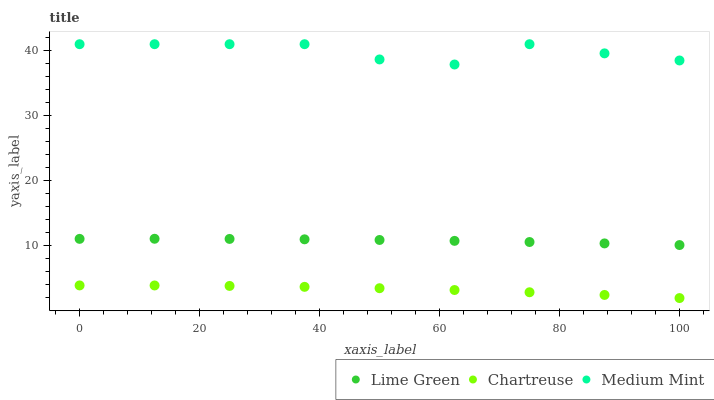Does Chartreuse have the minimum area under the curve?
Answer yes or no. Yes. Does Medium Mint have the maximum area under the curve?
Answer yes or no. Yes. Does Lime Green have the minimum area under the curve?
Answer yes or no. No. Does Lime Green have the maximum area under the curve?
Answer yes or no. No. Is Lime Green the smoothest?
Answer yes or no. Yes. Is Medium Mint the roughest?
Answer yes or no. Yes. Is Chartreuse the smoothest?
Answer yes or no. No. Is Chartreuse the roughest?
Answer yes or no. No. Does Chartreuse have the lowest value?
Answer yes or no. Yes. Does Lime Green have the lowest value?
Answer yes or no. No. Does Medium Mint have the highest value?
Answer yes or no. Yes. Does Lime Green have the highest value?
Answer yes or no. No. Is Chartreuse less than Lime Green?
Answer yes or no. Yes. Is Medium Mint greater than Chartreuse?
Answer yes or no. Yes. Does Chartreuse intersect Lime Green?
Answer yes or no. No. 